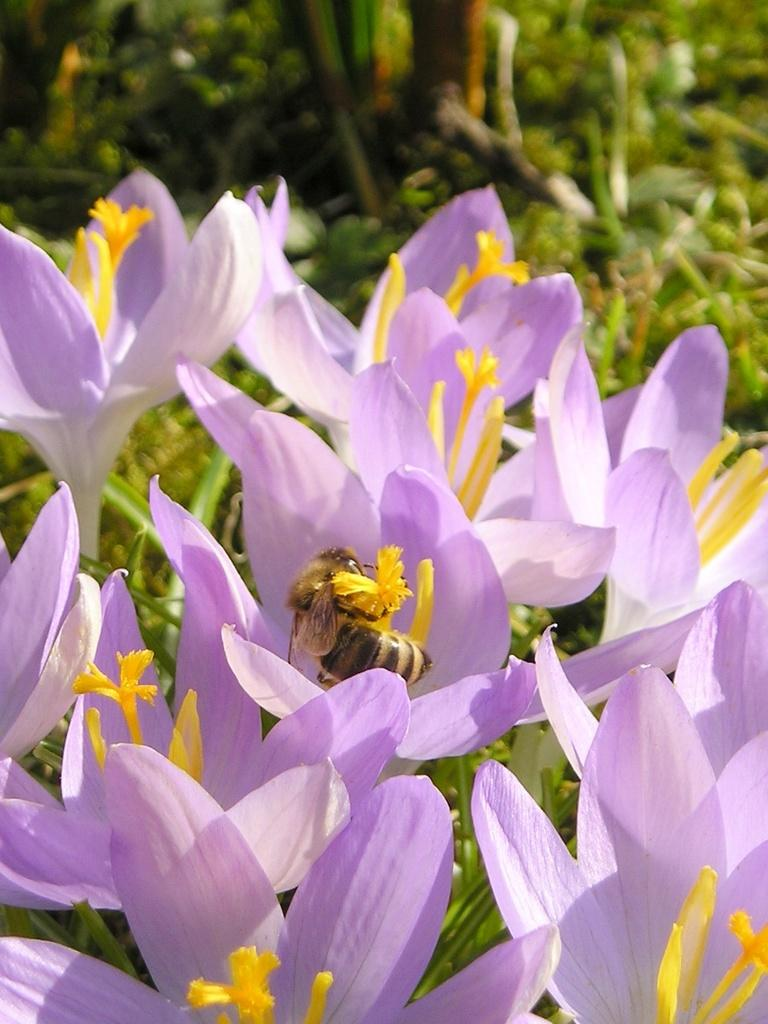What type of living organisms can be seen in the image? There are flowers and bees in the image. What might be the relationship between the flowers and the bees in the image? The bees may be pollinating the flowers in the image. Can you describe the background of the image? The background of the image is blurred. How much income do the brothers in the image earn? There are no brothers present in the image, so it is not possible to determine their income. What type of sky is visible in the image? The provided facts do not mention the sky, so it is not possible to determine the type of sky visible in the image. 